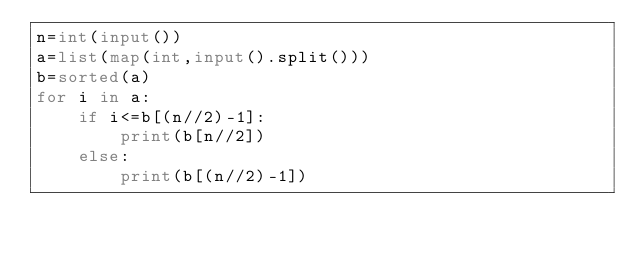<code> <loc_0><loc_0><loc_500><loc_500><_Python_>n=int(input())
a=list(map(int,input().split()))
b=sorted(a)
for i in a:
    if i<=b[(n//2)-1]:
        print(b[n//2])
    else:
        print(b[(n//2)-1])</code> 